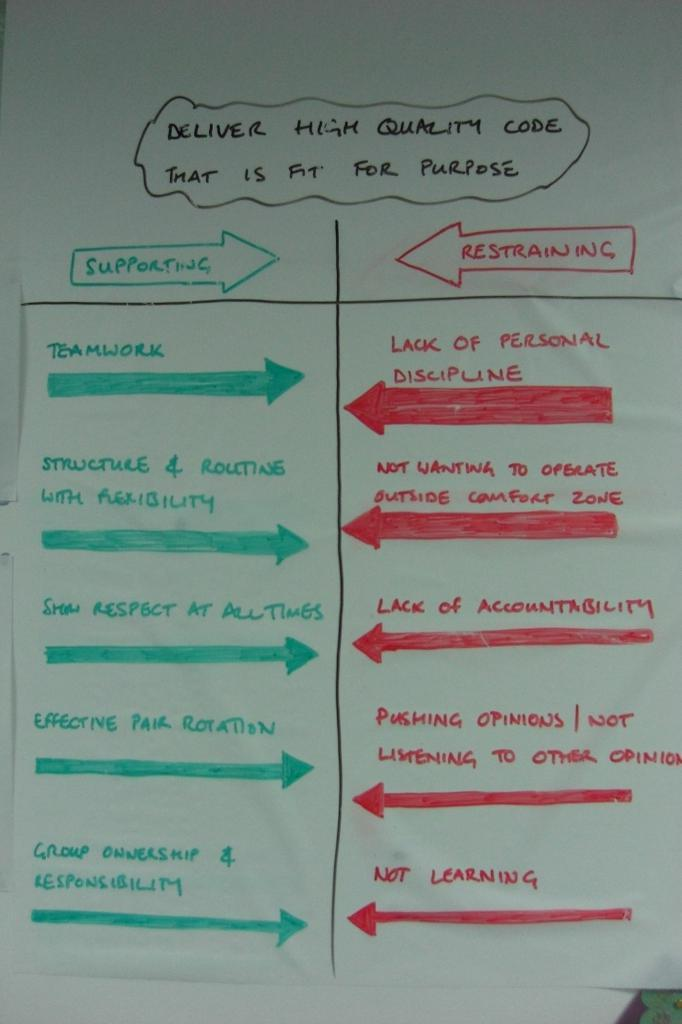What is present on the paper in the image? There is text present on the paper. Can you describe the paper in the image? The paper is visible in the image, and it has text on it. What type of thumb can be seen on the paper in the image? There is no thumb present on the paper in the image. Is there a hospital depicted on the paper in the image? There is no hospital depicted on the paper in the image. 